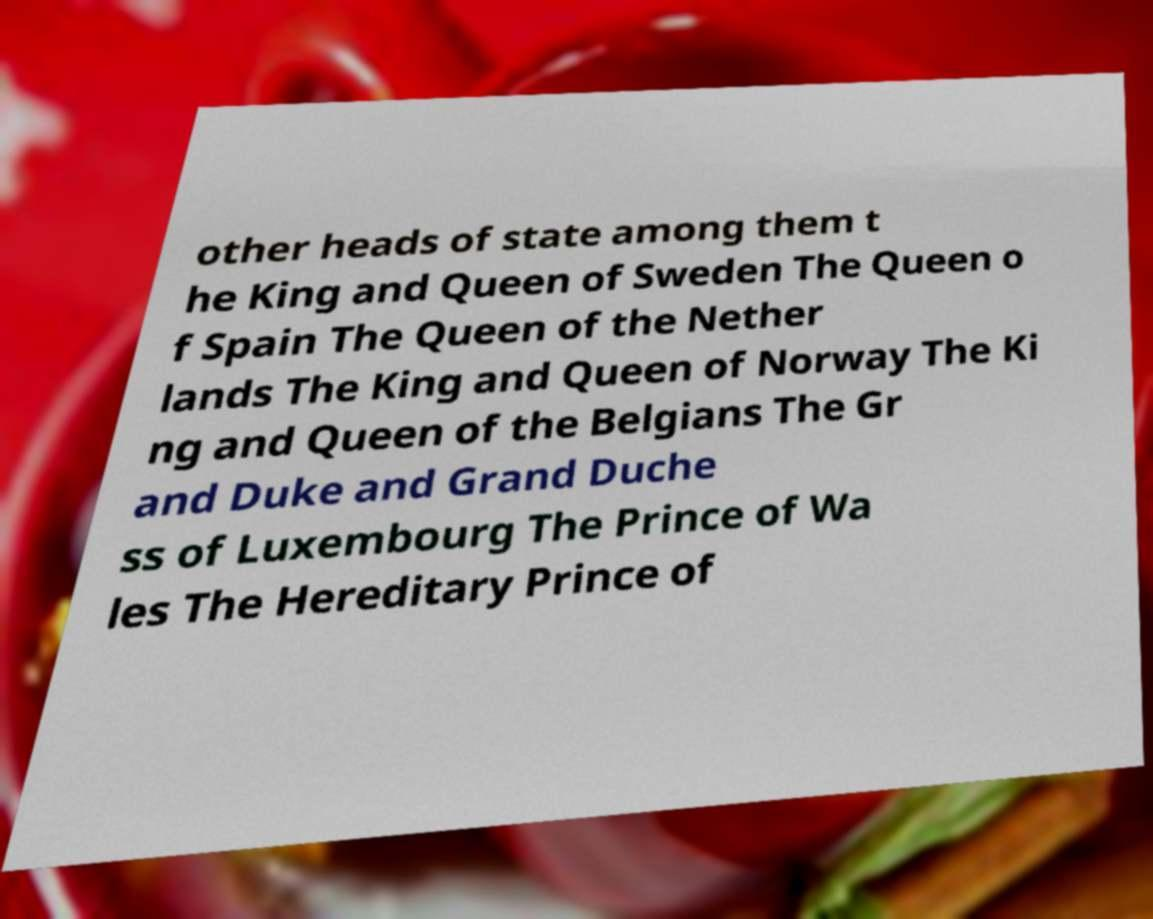What messages or text are displayed in this image? I need them in a readable, typed format. other heads of state among them t he King and Queen of Sweden The Queen o f Spain The Queen of the Nether lands The King and Queen of Norway The Ki ng and Queen of the Belgians The Gr and Duke and Grand Duche ss of Luxembourg The Prince of Wa les The Hereditary Prince of 